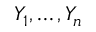Convert formula to latex. <formula><loc_0><loc_0><loc_500><loc_500>Y _ { 1 } , \dots , Y _ { n }</formula> 